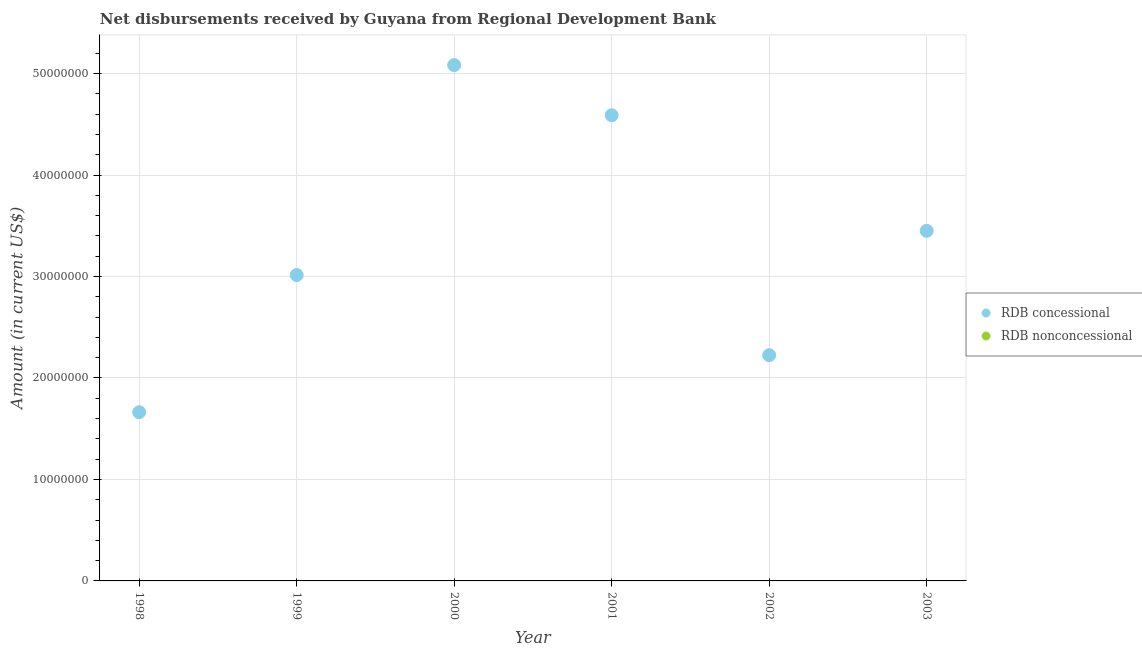How many different coloured dotlines are there?
Ensure brevity in your answer.  1. What is the net concessional disbursements from rdb in 1998?
Offer a very short reply. 1.66e+07. Across all years, what is the minimum net concessional disbursements from rdb?
Give a very brief answer. 1.66e+07. In which year was the net concessional disbursements from rdb maximum?
Offer a very short reply. 2000. What is the difference between the net concessional disbursements from rdb in 2002 and that in 2003?
Offer a terse response. -1.23e+07. What is the difference between the net non concessional disbursements from rdb in 2001 and the net concessional disbursements from rdb in 2002?
Your response must be concise. -2.22e+07. What is the average net non concessional disbursements from rdb per year?
Your answer should be very brief. 0. In how many years, is the net non concessional disbursements from rdb greater than 18000000 US$?
Your response must be concise. 0. What is the ratio of the net concessional disbursements from rdb in 1999 to that in 2002?
Ensure brevity in your answer.  1.36. What is the difference between the highest and the second highest net concessional disbursements from rdb?
Your answer should be very brief. 4.95e+06. What is the difference between the highest and the lowest net concessional disbursements from rdb?
Your response must be concise. 3.42e+07. Is the sum of the net concessional disbursements from rdb in 2001 and 2003 greater than the maximum net non concessional disbursements from rdb across all years?
Offer a terse response. Yes. Does the net non concessional disbursements from rdb monotonically increase over the years?
Your answer should be very brief. No. How many years are there in the graph?
Give a very brief answer. 6. Does the graph contain any zero values?
Your answer should be compact. Yes. Does the graph contain grids?
Ensure brevity in your answer.  Yes. Where does the legend appear in the graph?
Offer a terse response. Center right. What is the title of the graph?
Your response must be concise. Net disbursements received by Guyana from Regional Development Bank. Does "Nitrous oxide" appear as one of the legend labels in the graph?
Provide a short and direct response. No. What is the label or title of the X-axis?
Your response must be concise. Year. What is the Amount (in current US$) in RDB concessional in 1998?
Provide a short and direct response. 1.66e+07. What is the Amount (in current US$) in RDB concessional in 1999?
Offer a terse response. 3.01e+07. What is the Amount (in current US$) of RDB nonconcessional in 1999?
Offer a very short reply. 0. What is the Amount (in current US$) of RDB concessional in 2000?
Your answer should be compact. 5.08e+07. What is the Amount (in current US$) of RDB nonconcessional in 2000?
Make the answer very short. 0. What is the Amount (in current US$) in RDB concessional in 2001?
Provide a succinct answer. 4.59e+07. What is the Amount (in current US$) of RDB nonconcessional in 2001?
Provide a short and direct response. 0. What is the Amount (in current US$) of RDB concessional in 2002?
Your answer should be compact. 2.22e+07. What is the Amount (in current US$) in RDB concessional in 2003?
Your answer should be compact. 3.45e+07. Across all years, what is the maximum Amount (in current US$) in RDB concessional?
Keep it short and to the point. 5.08e+07. Across all years, what is the minimum Amount (in current US$) of RDB concessional?
Provide a succinct answer. 1.66e+07. What is the total Amount (in current US$) in RDB concessional in the graph?
Offer a very short reply. 2.00e+08. What is the total Amount (in current US$) in RDB nonconcessional in the graph?
Your answer should be compact. 0. What is the difference between the Amount (in current US$) in RDB concessional in 1998 and that in 1999?
Provide a short and direct response. -1.35e+07. What is the difference between the Amount (in current US$) of RDB concessional in 1998 and that in 2000?
Give a very brief answer. -3.42e+07. What is the difference between the Amount (in current US$) in RDB concessional in 1998 and that in 2001?
Provide a short and direct response. -2.93e+07. What is the difference between the Amount (in current US$) in RDB concessional in 1998 and that in 2002?
Keep it short and to the point. -5.62e+06. What is the difference between the Amount (in current US$) in RDB concessional in 1998 and that in 2003?
Offer a very short reply. -1.79e+07. What is the difference between the Amount (in current US$) in RDB concessional in 1999 and that in 2000?
Provide a succinct answer. -2.07e+07. What is the difference between the Amount (in current US$) in RDB concessional in 1999 and that in 2001?
Keep it short and to the point. -1.57e+07. What is the difference between the Amount (in current US$) in RDB concessional in 1999 and that in 2002?
Keep it short and to the point. 7.90e+06. What is the difference between the Amount (in current US$) in RDB concessional in 1999 and that in 2003?
Give a very brief answer. -4.36e+06. What is the difference between the Amount (in current US$) in RDB concessional in 2000 and that in 2001?
Provide a succinct answer. 4.95e+06. What is the difference between the Amount (in current US$) of RDB concessional in 2000 and that in 2002?
Offer a terse response. 2.86e+07. What is the difference between the Amount (in current US$) in RDB concessional in 2000 and that in 2003?
Offer a very short reply. 1.63e+07. What is the difference between the Amount (in current US$) in RDB concessional in 2001 and that in 2002?
Give a very brief answer. 2.36e+07. What is the difference between the Amount (in current US$) of RDB concessional in 2001 and that in 2003?
Your response must be concise. 1.14e+07. What is the difference between the Amount (in current US$) in RDB concessional in 2002 and that in 2003?
Give a very brief answer. -1.23e+07. What is the average Amount (in current US$) in RDB concessional per year?
Your answer should be compact. 3.34e+07. What is the ratio of the Amount (in current US$) in RDB concessional in 1998 to that in 1999?
Keep it short and to the point. 0.55. What is the ratio of the Amount (in current US$) of RDB concessional in 1998 to that in 2000?
Your answer should be very brief. 0.33. What is the ratio of the Amount (in current US$) in RDB concessional in 1998 to that in 2001?
Make the answer very short. 0.36. What is the ratio of the Amount (in current US$) in RDB concessional in 1998 to that in 2002?
Your answer should be compact. 0.75. What is the ratio of the Amount (in current US$) in RDB concessional in 1998 to that in 2003?
Offer a very short reply. 0.48. What is the ratio of the Amount (in current US$) in RDB concessional in 1999 to that in 2000?
Offer a very short reply. 0.59. What is the ratio of the Amount (in current US$) in RDB concessional in 1999 to that in 2001?
Ensure brevity in your answer.  0.66. What is the ratio of the Amount (in current US$) in RDB concessional in 1999 to that in 2002?
Make the answer very short. 1.36. What is the ratio of the Amount (in current US$) of RDB concessional in 1999 to that in 2003?
Offer a terse response. 0.87. What is the ratio of the Amount (in current US$) in RDB concessional in 2000 to that in 2001?
Your response must be concise. 1.11. What is the ratio of the Amount (in current US$) in RDB concessional in 2000 to that in 2002?
Make the answer very short. 2.29. What is the ratio of the Amount (in current US$) in RDB concessional in 2000 to that in 2003?
Offer a very short reply. 1.47. What is the ratio of the Amount (in current US$) in RDB concessional in 2001 to that in 2002?
Your response must be concise. 2.06. What is the ratio of the Amount (in current US$) in RDB concessional in 2001 to that in 2003?
Your answer should be very brief. 1.33. What is the ratio of the Amount (in current US$) of RDB concessional in 2002 to that in 2003?
Provide a short and direct response. 0.64. What is the difference between the highest and the second highest Amount (in current US$) of RDB concessional?
Your answer should be very brief. 4.95e+06. What is the difference between the highest and the lowest Amount (in current US$) of RDB concessional?
Ensure brevity in your answer.  3.42e+07. 